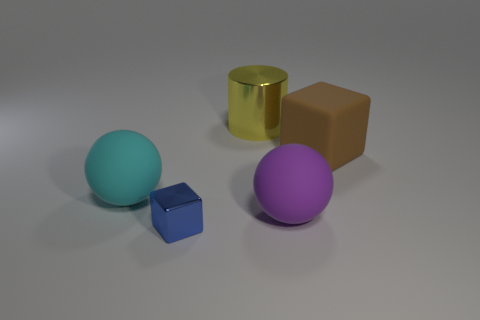Add 1 small green metal cubes. How many objects exist? 6 Subtract all blocks. How many objects are left? 3 Subtract all cyan blocks. Subtract all gray spheres. How many blocks are left? 2 Add 1 purple things. How many purple things are left? 2 Add 1 large matte things. How many large matte things exist? 4 Subtract 0 cyan blocks. How many objects are left? 5 Subtract all cylinders. Subtract all large metal objects. How many objects are left? 3 